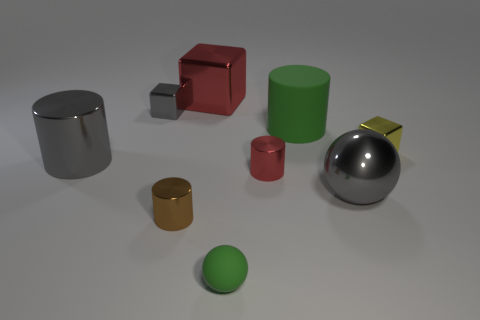Subtract all small metallic blocks. How many blocks are left? 1 Subtract all blue cylinders. Subtract all green spheres. How many cylinders are left? 4 Subtract all cubes. How many objects are left? 6 Add 4 red metallic cylinders. How many red metallic cylinders are left? 5 Add 2 cyan cylinders. How many cyan cylinders exist? 2 Subtract 0 blue spheres. How many objects are left? 9 Subtract all gray cylinders. Subtract all small objects. How many objects are left? 3 